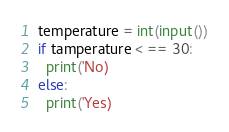Convert code to text. <code><loc_0><loc_0><loc_500><loc_500><_Python_>temperature = int(input())
if tamperature < == 30:
  print('No)
else:
  print('Yes)</code> 